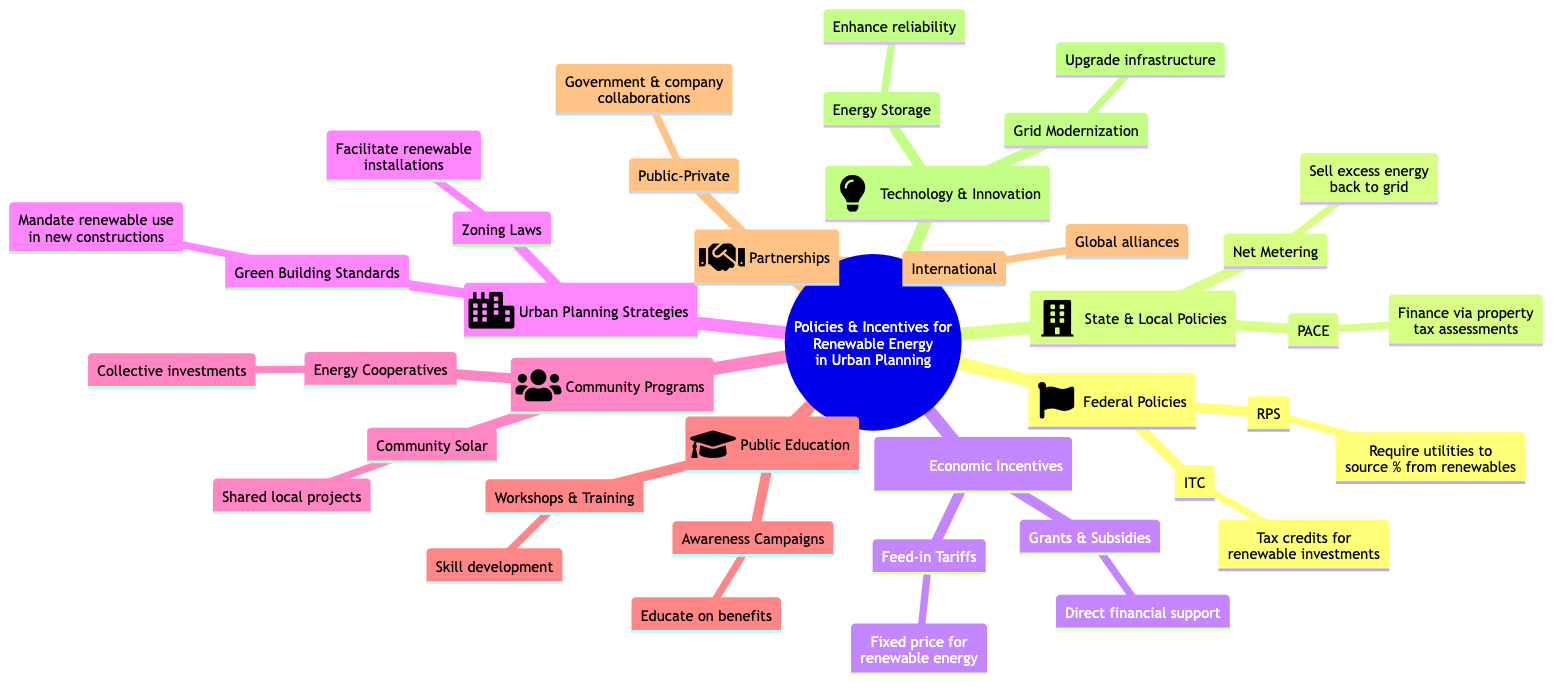What are the two main categories of policies outlined in the diagram? The diagram lists "Federal Policies" and "State And Local Policies" as the two main categories under the root "Policies & Incentives for Renewable Energy in Urban Planning."
Answer: Federal Policies, State And Local Policies How many economic incentives are detailed in the diagram? The diagram specifies two economic incentives: "Grants And Subsidies" and "Feed-In Tariffs." Thus, the total count is two.
Answer: 2 What does PACE stand for in the context of policies? PACE refers to "Property Assessed Clean Energy," which is explained in the diagram.
Answer: Property Assessed Clean Energy Which urban planning strategy mandates the use of renewable energy in new constructions? The diagram identifies "Green Building Standards" as the strategy that mandates or encourages the use of renewable energy.
Answer: Green Building Standards Which community program allows collective investments in renewable energy facilities? The diagram highlights "Energy Cooperatives" as the program that enables groups to invest collectively in renewable energy.
Answer: Energy Cooperatives What is the primary goal of awareness campaigns according to the diagram? The diagram states that the goal of awareness campaigns is to educate the public about the benefits of renewable energy, establishing a direct link between the program and its objective.
Answer: Educate on benefits How do public-private partnerships contribute to renewable energy projects? Public-private partnerships involve government collaboration with private companies, linking these entities for the development of renewable energy projects as indicated in the diagram.
Answer: Government collaboration with private companies What is one technology innovation mentioned that improves renewable energy reliability? The diagram mentions "Energy Storage Solutions" as an innovation that enhances the reliability of renewable energy systems.
Answer: Energy Storage Solutions What type of economic incentive provides direct financial support for renewable energy projects? The diagram lists "Grants And Subsidies" as the type of economic incentive that offers direct financial support for such projects.
Answer: Grants And Subsidies 